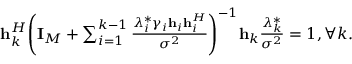Convert formula to latex. <formula><loc_0><loc_0><loc_500><loc_500>\begin{array} { r } { { h } _ { k } ^ { H } { \left ( { { { I } _ { M } } + \sum _ { i = 1 } ^ { k - 1 } { \frac { { \lambda _ { i } ^ { * } { \gamma _ { i } } { { h } _ { i } } { h } _ { i } ^ { H } } } { { { \sigma ^ { 2 } } } } } } \right ) ^ { - 1 } } { { h } _ { k } } \frac { { \lambda _ { k } ^ { * } } } { { { \sigma ^ { 2 } } } } = 1 , \forall k . } \end{array}</formula> 